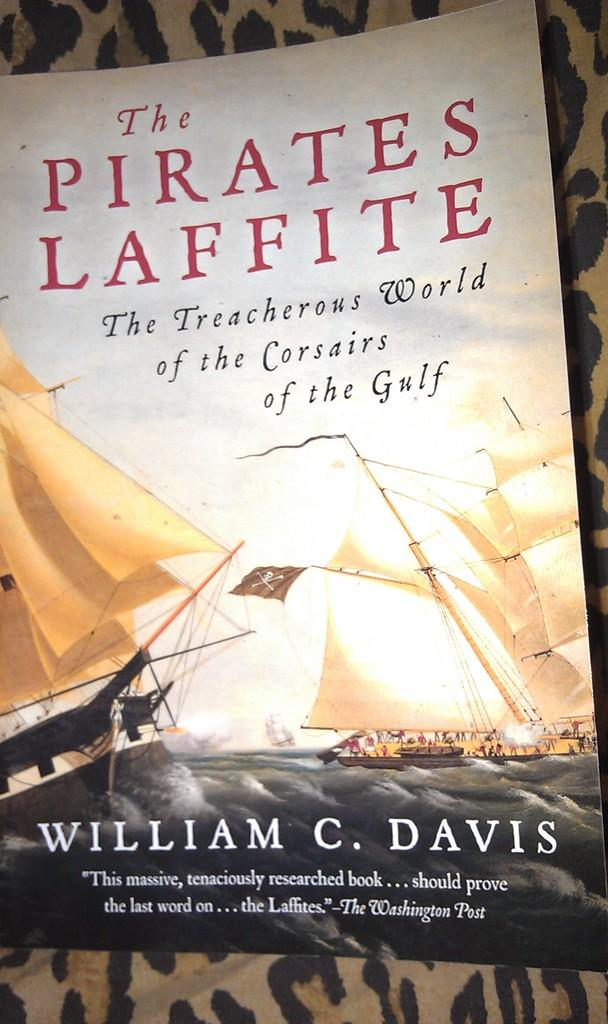Provide a one-sentence caption for the provided image. A book called the Pirates Laffite by William C. Davis. 